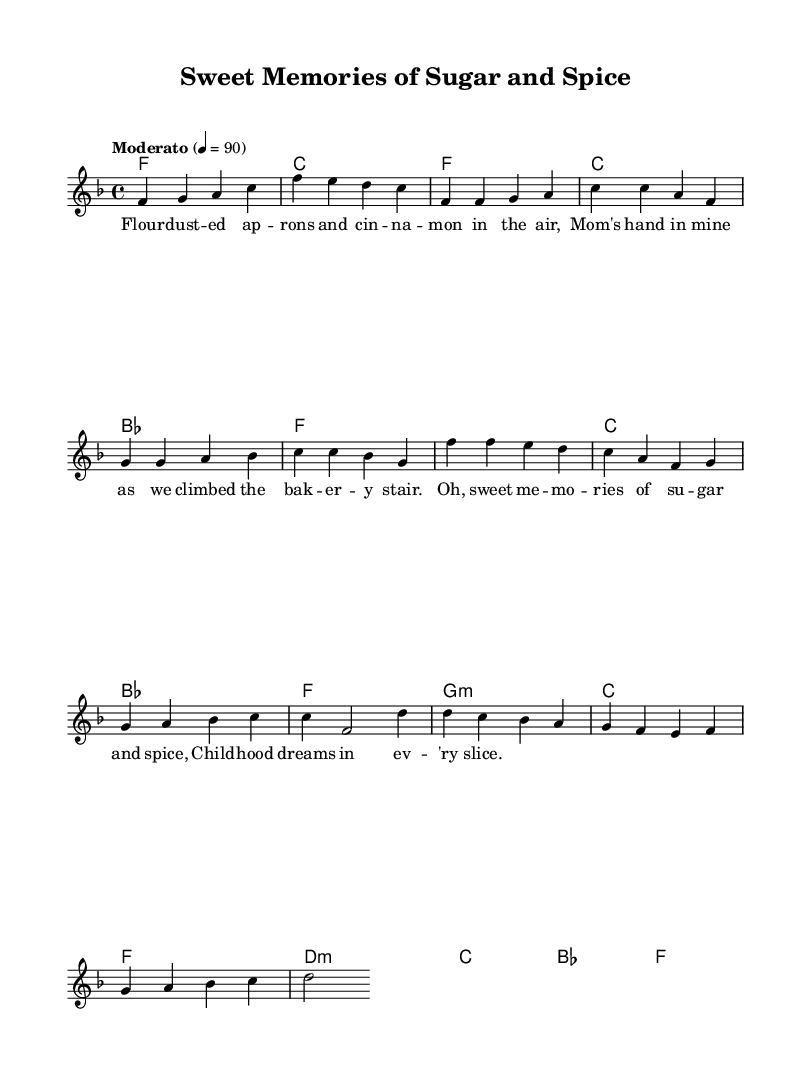What is the key signature of this music? The key signature is F major, which has one flat (B flat). This can be identified by looking at the key signature displayed at the beginning of the score, right after the clef.
Answer: F major What is the time signature of the piece? The time signature is 4/4, indicating that there are four beats per measure and a quarter note receives one beat. This is found right after the key signature in the score.
Answer: 4/4 What is the tempo marking for this piece? The tempo marking is "Moderato," which typically means moderately fast. This is stated above the staff in the tempo indication section.
Answer: Moderato How many measures are in the chorus? The chorus consists of four measures, which can be counted by looking at the section where the lyrics for the chorus are written along with the corresponding musical notation.
Answer: 4 measures In which section does the lyrics mention "Mom's hand in mine"? The lyrics mentioning "Mom's hand in mine" can be found in the verse section of the sheet music. This can be determined by reading the lyrics aligned with the corresponding melody noted before the chorus.
Answer: Verse What is the last chord in the bridge? The last chord in the bridge is F major. You can identify this by observing the chord symbols right above the staff in the harmonies section. The bridge ends with the chord symbol "f".
Answer: F 